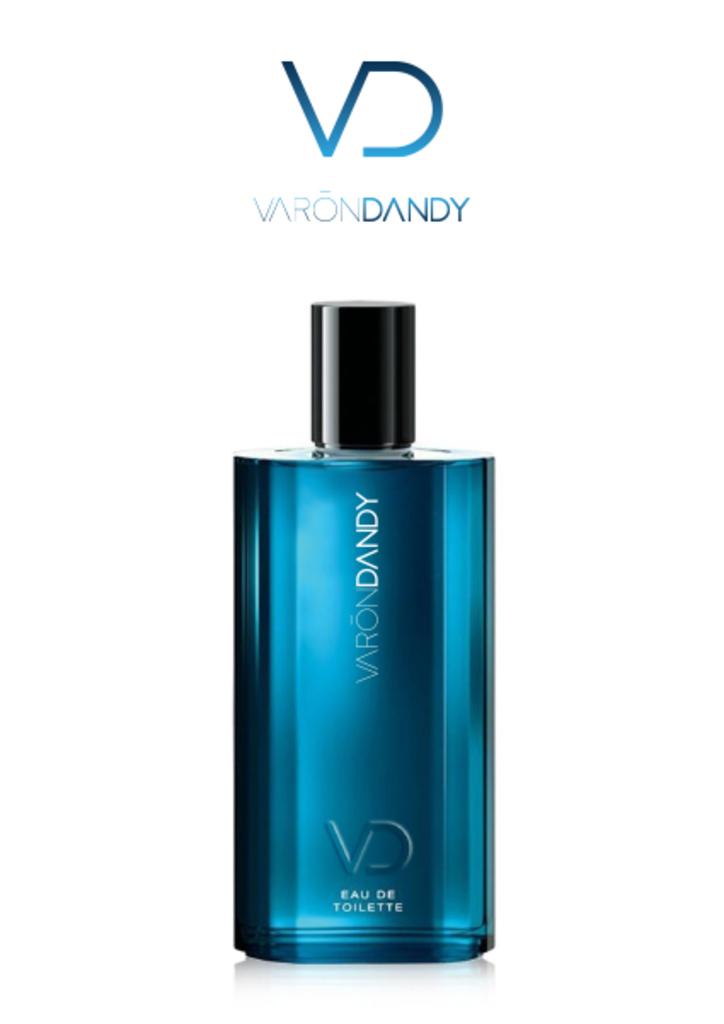What brand is represented in this ad?
Provide a succinct answer. Varondandy. What is in this bottle?
Your answer should be compact. Varon dandy. 